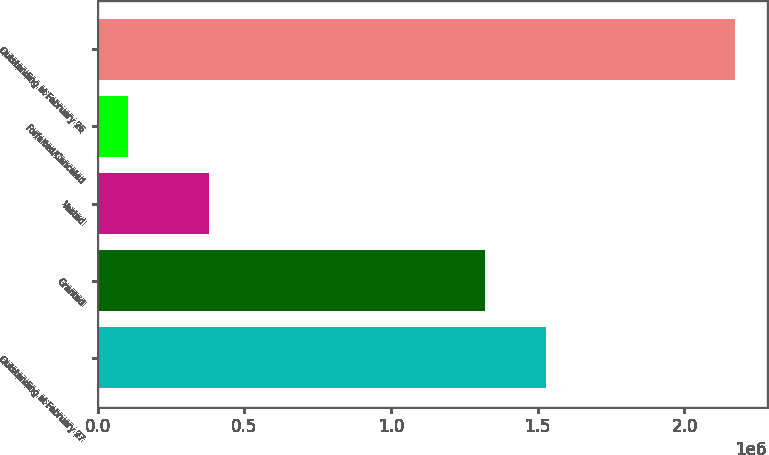Convert chart to OTSL. <chart><loc_0><loc_0><loc_500><loc_500><bar_chart><fcel>Outstanding at February 27<fcel>Granted<fcel>Vested<fcel>Forfeited/Canceled<fcel>Outstanding at February 26<nl><fcel>1.5279e+06<fcel>1.321e+06<fcel>380000<fcel>102000<fcel>2.171e+06<nl></chart> 